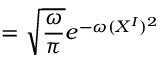<formula> <loc_0><loc_0><loc_500><loc_500>= \sqrt { \frac { \omega } { \pi } } e ^ { - \omega ( X ^ { I } ) ^ { 2 } }</formula> 